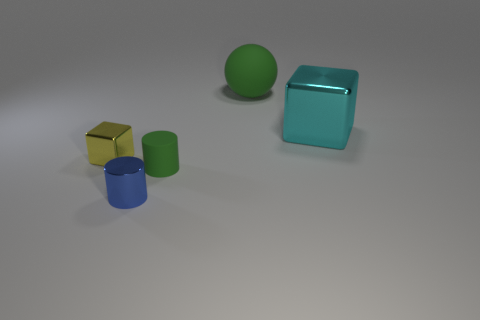Add 4 cyan metal objects. How many objects exist? 9 Subtract all balls. How many objects are left? 4 Add 4 cylinders. How many cylinders are left? 6 Add 3 rubber balls. How many rubber balls exist? 4 Subtract 0 gray cylinders. How many objects are left? 5 Subtract all big cyan cubes. Subtract all small metallic cylinders. How many objects are left? 3 